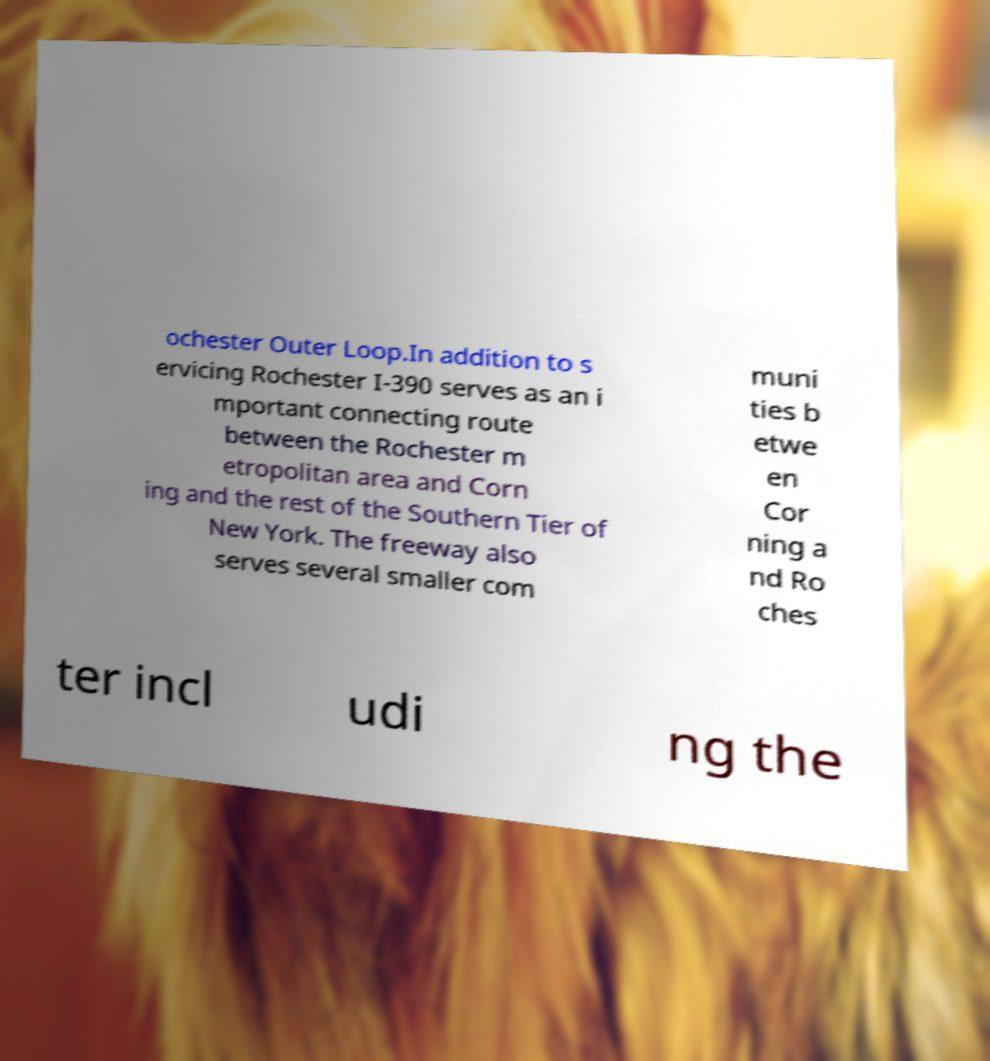What messages or text are displayed in this image? I need them in a readable, typed format. ochester Outer Loop.In addition to s ervicing Rochester I-390 serves as an i mportant connecting route between the Rochester m etropolitan area and Corn ing and the rest of the Southern Tier of New York. The freeway also serves several smaller com muni ties b etwe en Cor ning a nd Ro ches ter incl udi ng the 